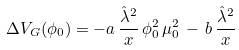<formula> <loc_0><loc_0><loc_500><loc_500>\Delta V _ { G } ( \phi _ { 0 } ) = - a \, \frac { { \hat { \lambda } } ^ { 2 } } { x } \, \phi _ { 0 } ^ { 2 } \, \mu _ { 0 } ^ { 2 } \, - \, b \, \frac { { \hat { \lambda } ^ { 2 } } } { x }</formula> 